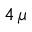Convert formula to latex. <formula><loc_0><loc_0><loc_500><loc_500>4 \, \mu</formula> 